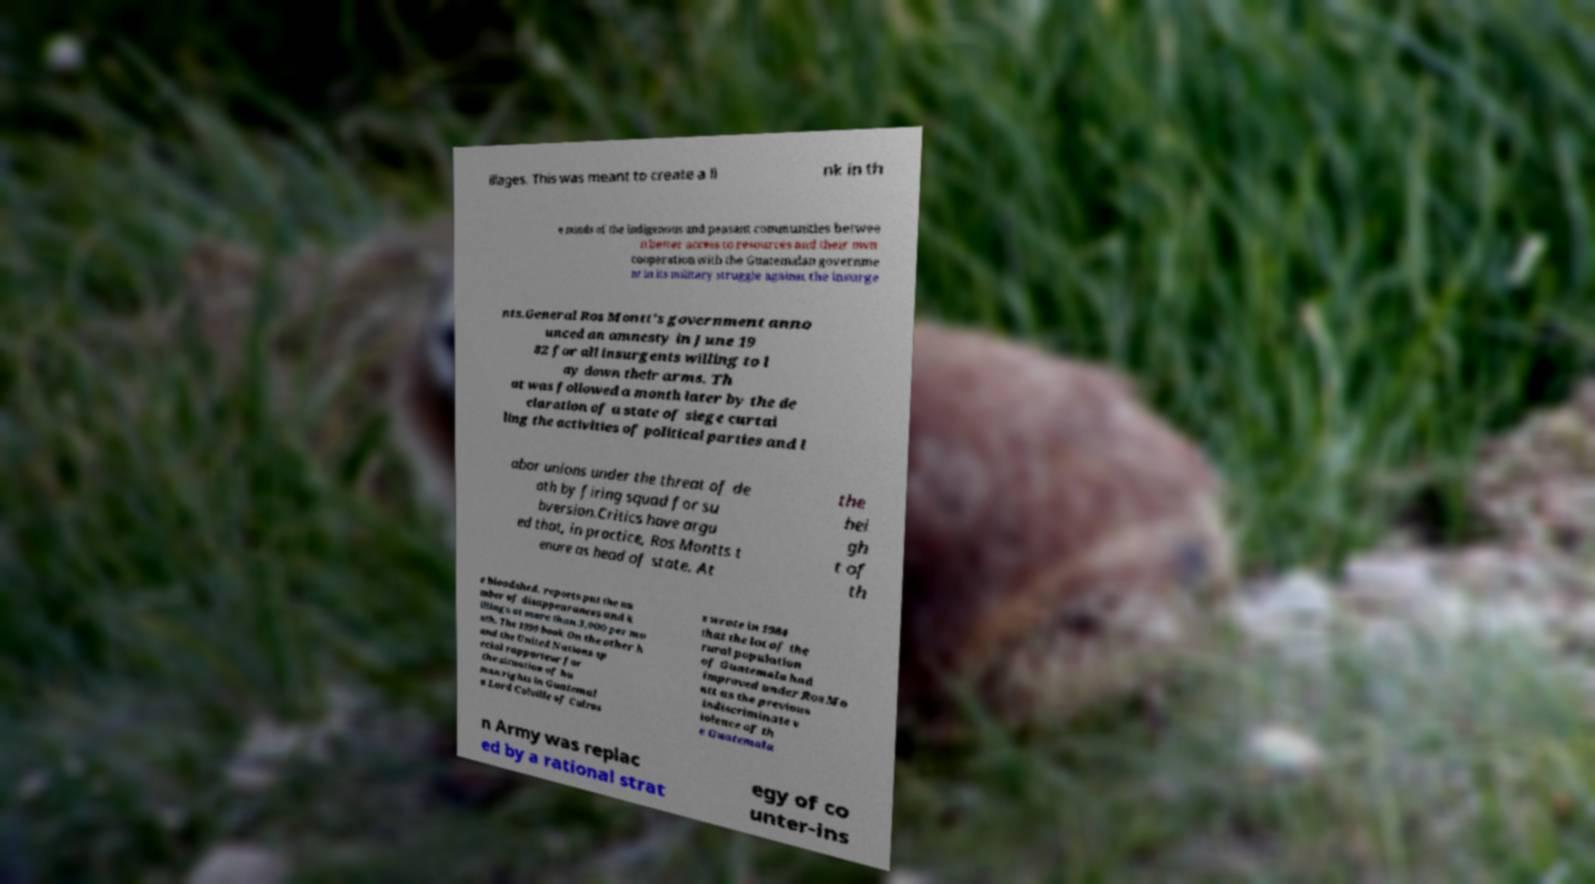What messages or text are displayed in this image? I need them in a readable, typed format. illages. This was meant to create a li nk in th e minds of the indigenous and peasant communities betwee n better access to resources and their own cooperation with the Guatemalan governme nt in its military struggle against the insurge nts.General Ros Montt's government anno unced an amnesty in June 19 82 for all insurgents willing to l ay down their arms. Th at was followed a month later by the de claration of a state of siege curtai ling the activities of political parties and l abor unions under the threat of de ath by firing squad for su bversion.Critics have argu ed that, in practice, Ros Montts t enure as head of state. At the hei gh t of th e bloodshed, reports put the nu mber of disappearances and k illings at more than 3,000 per mo nth. The 1999 book On the other h and the United Nations sp ecial rapporteur for the situation of hu man rights in Guatemal a Lord Colville of Culros s wrote in 1984 that the lot of the rural population of Guatemala had improved under Ros Mo ntt as the previous indiscriminate v iolence of th e Guatemala n Army was replac ed by a rational strat egy of co unter-ins 